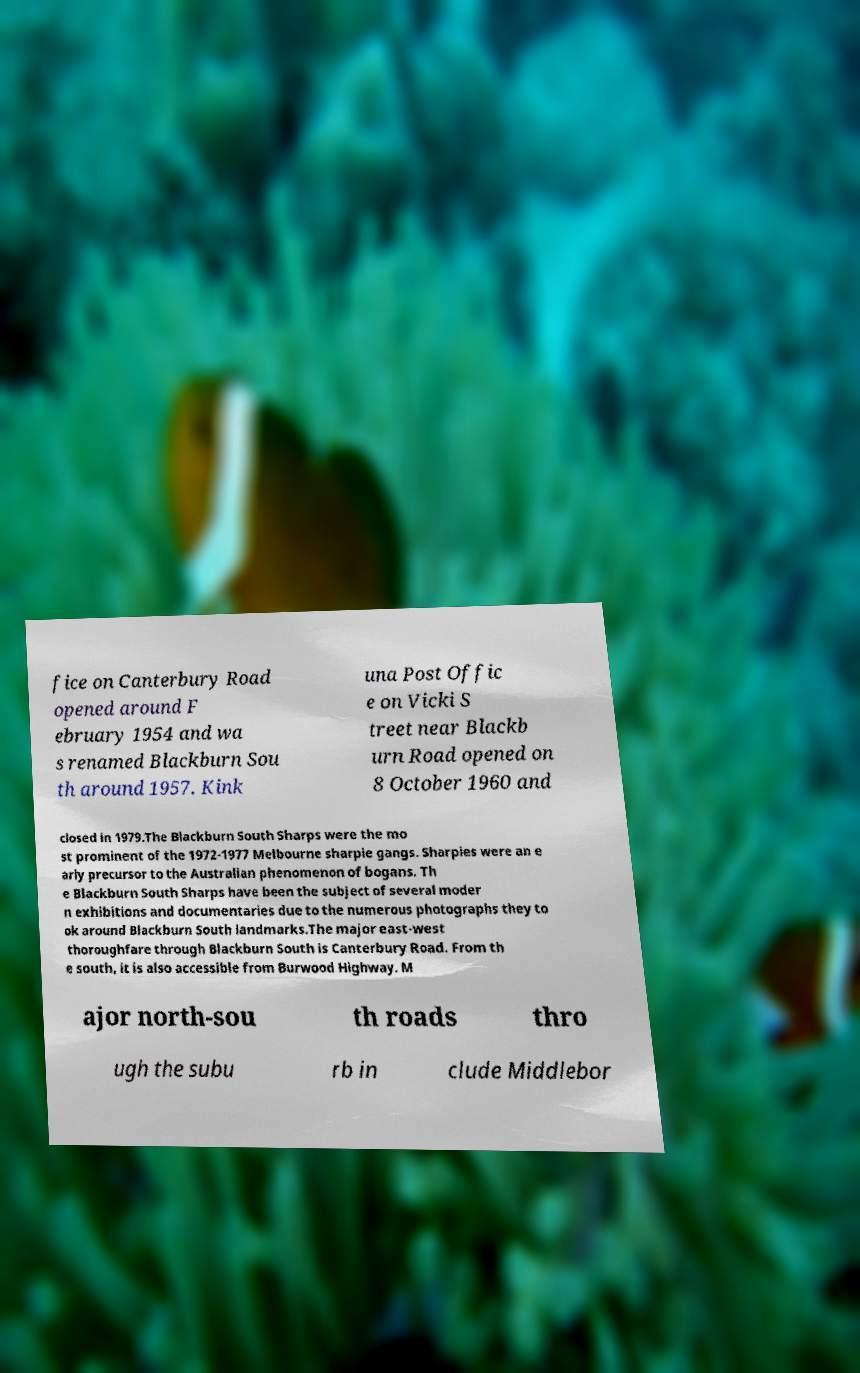I need the written content from this picture converted into text. Can you do that? fice on Canterbury Road opened around F ebruary 1954 and wa s renamed Blackburn Sou th around 1957. Kink una Post Offic e on Vicki S treet near Blackb urn Road opened on 8 October 1960 and closed in 1979.The Blackburn South Sharps were the mo st prominent of the 1972-1977 Melbourne sharpie gangs. Sharpies were an e arly precursor to the Australian phenomenon of bogans. Th e Blackburn South Sharps have been the subject of several moder n exhibitions and documentaries due to the numerous photographs they to ok around Blackburn South landmarks.The major east-west thoroughfare through Blackburn South is Canterbury Road. From th e south, it is also accessible from Burwood Highway. M ajor north-sou th roads thro ugh the subu rb in clude Middlebor 